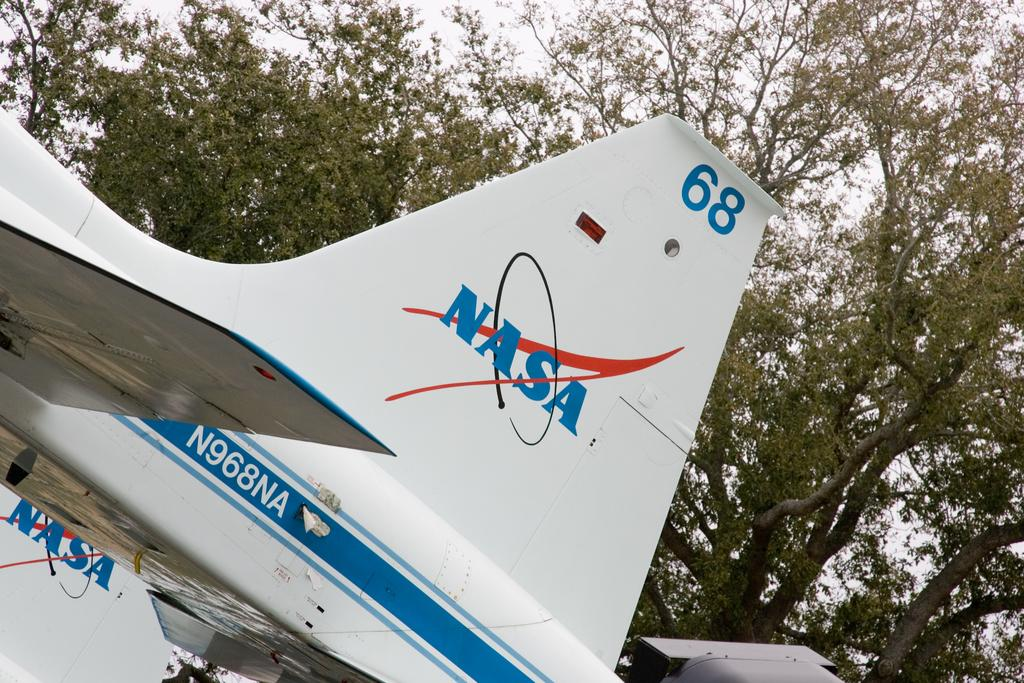<image>
Describe the image concisely. NASA airplane wing numbered N968NA, plane number 68. 